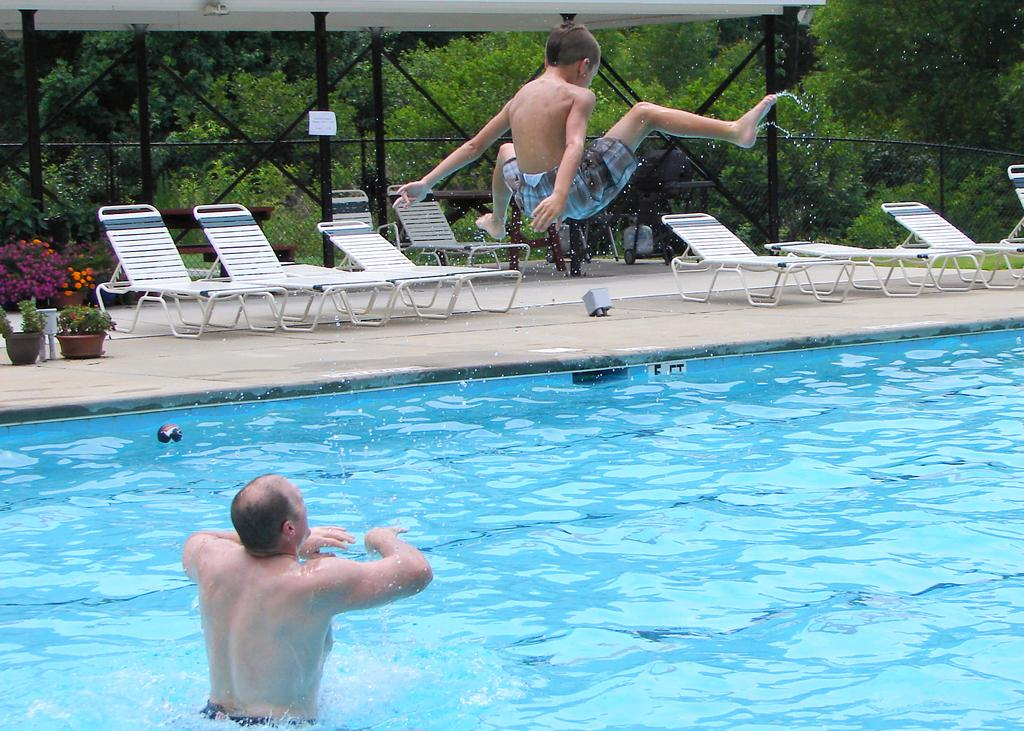What is the person in the image doing? The person is in the water. What can be seen in the background of the image? There are hammock chairs, plants with pots, mesh rods, and trees in the background. Can you describe the hammock chairs in the background? The hammock chairs are on the walkway in the background. What type of vegetation is present in the background? There are plants with pots and trees in the background. What is the boy in the image doing? There is a boy in the air, which suggests he might be jumping or flying. What type of leather is visible on the coat worn by the person in the water? There is no leather or coat mentioned in the image; the person is simply in the water. 